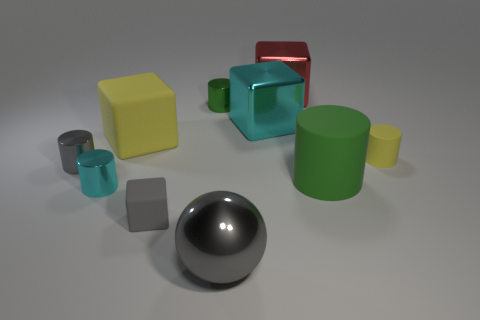What number of objects are either cyan objects behind the small matte cylinder or cubes left of the large gray thing?
Provide a succinct answer. 3. What size is the gray cube that is the same material as the small yellow cylinder?
Your response must be concise. Small. There is a yellow thing that is to the right of the large yellow thing; does it have the same shape as the large yellow object?
Provide a short and direct response. No. There is a cylinder that is the same color as the metal ball; what size is it?
Make the answer very short. Small. How many red things are either large matte cubes or metal objects?
Offer a very short reply. 1. What number of other things are the same shape as the tiny cyan thing?
Your answer should be very brief. 4. The metal object that is both in front of the yellow rubber block and behind the cyan metallic cylinder has what shape?
Offer a very short reply. Cylinder. There is a red thing; are there any green objects on the right side of it?
Offer a terse response. Yes. There is a gray object that is the same shape as the big yellow rubber object; what is its size?
Your answer should be very brief. Small. Does the green metallic thing have the same shape as the tiny gray metallic object?
Ensure brevity in your answer.  Yes. 